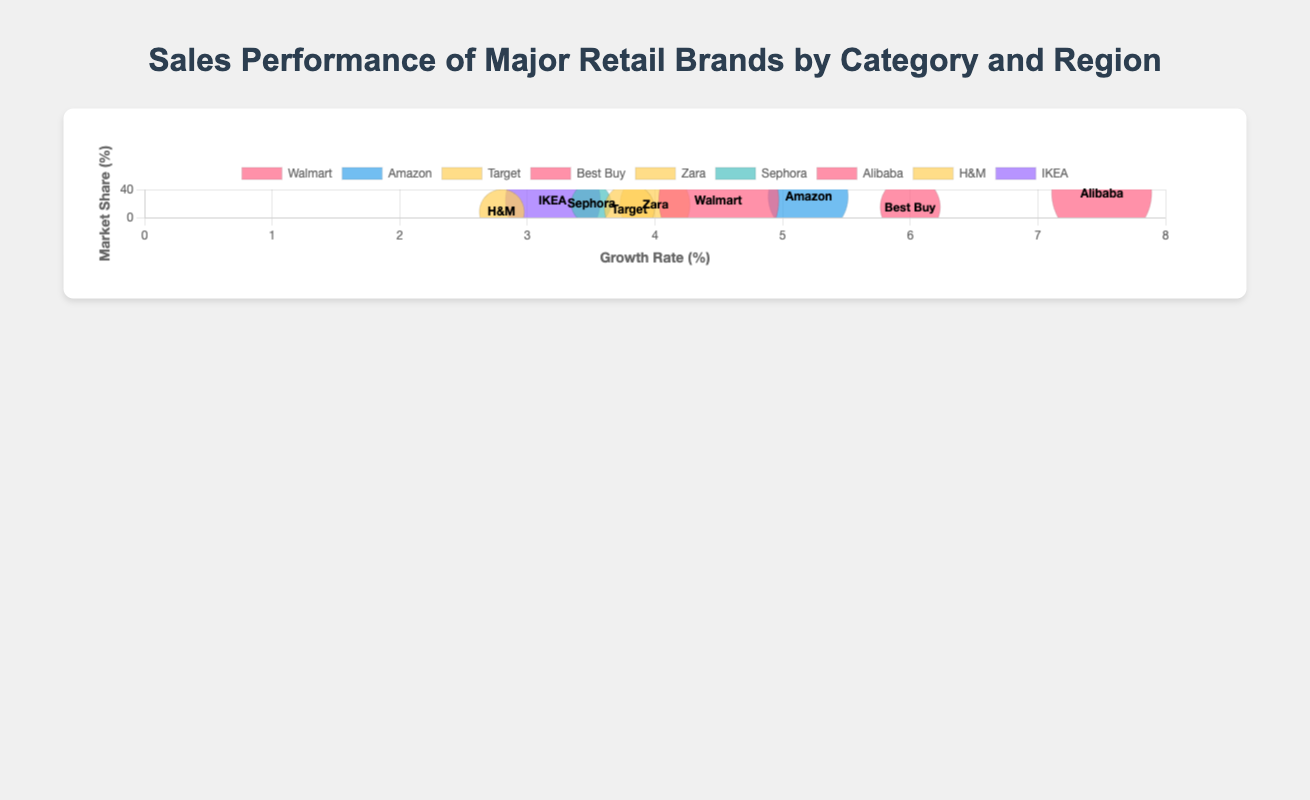What's the title of the figure? The title of the figure is displayed at the top center of the chart, stating the key topic it visualizes: "Sales Performance of Major Retail Brands by Category and Region."
Answer: Sales Performance of Major Retail Brands by Category and Region How many brands are represented in the chart? By looking at the number of distinct data points (bubbles) on the chart and referring to the legend, count each unique brand listed: Walmart, Amazon, Target, Best Buy, Zara, Sephora, Alibaba, H&M, IKEA.
Answer: Nine Which brand has the highest market share and what is its value? Determine the highest value on the y-axis among all bubbles, then check the tooltip or label for that specific data point. Alibaba has the highest market share of 35%.
Answer: Alibaba, 35% Which brand operates in the "Cosmetics" category and what is its market share? Identify the color representing the "Cosmetics" category from the legend and locate the corresponding bubble (Sephora) and its market share value from the vertical axis or tooltip.
Answer: Sephora, 20% What is the growth rate of IKEA, and how does it compare to the average growth rate of all brands? Locate the bubble for IKEA, find its x-axis value (growth rate: 3.2). Calculate the average growth rate of all brands: sum all growth rates (4.5 + 5.2 + 3.8 + 6.0 + 4.0 + 3.5 + 7.5 + 2.8 + 3.2) = 40.5, then divide by the number of brands (9). Average growth rate = 40.5/9 ≈ 4.5. IKEA's growth rate is 3.2, which is lower than the average.
Answer: IKEA: 3.2%, Average: 4.5% Which brand in Asia has the highest sales, and what are those exact sales numbers? Focus on the region label to filter bubbles operating in Asia. Compare their sales values: Best Buy ($600,000), Alibaba ($1,000,000), H&M ($450,000). The highest is Alibaba with $1,000,000.
Answer: Alibaba, $1,000,000 Which brand in North America has the lowest growth rate, and what is its value? Filter bubbles in the North America region. Compare their growth rates: Walmart (4.5%), Target (3.8%), Sephora (3.5%). The lowest rate is Sephora with 3.5%.
Answer: Sephora, 3.5% By how much does the market share of Amazon exceed that of Target? Find the market share values on the y-axis or tooltip for Amazon (30%) and Target (12%). Subtract Target's market share from Amazon's market share: 30% - 12% = 18%.
Answer: 18% What are the sales and growth rate for brands in the Clothing category? Identify the color for "Clothing" from the legend, find sales and growth rate for Target (Sales: $500,000, Growth Rate: 3.8%), Zara (Sales: $700,000, Growth Rate: 4.0%), H&M (Sales: $450,000, Growth Rate: 2.8%).
Answer: Target: $500,000, 3.8%; Zara: $700,000, 4.0%; H&M: $450,000, 2.8% Which region has the highest number of brands, and how many brands are there from that region? Categorize the bubbles by their regions. Count the number of brands in North America (Walmart, Target, Sephora), Europe (Amazon, Zara, IKEA), and Asia (Best Buy, Alibaba, H&M). Asia has the highest number with three brands.
Answer: Asia, 3 